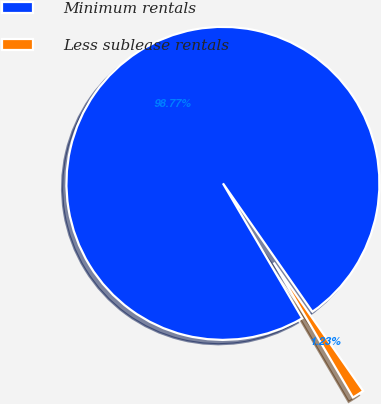<chart> <loc_0><loc_0><loc_500><loc_500><pie_chart><fcel>Minimum rentals<fcel>Less sublease rentals<nl><fcel>98.77%<fcel>1.23%<nl></chart> 